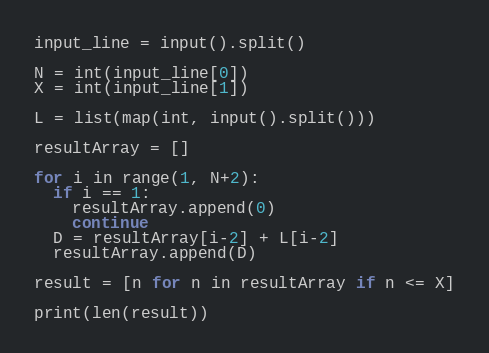Convert code to text. <code><loc_0><loc_0><loc_500><loc_500><_Python_>input_line = input().split()

N = int(input_line[0])
X = int(input_line[1])

L = list(map(int, input().split()))

resultArray = []

for i in range(1, N+2):
  if i == 1:
    resultArray.append(0)
    continue
  D = resultArray[i-2] + L[i-2]
  resultArray.append(D)

result = [n for n in resultArray if n <= X]

print(len(result))
</code> 